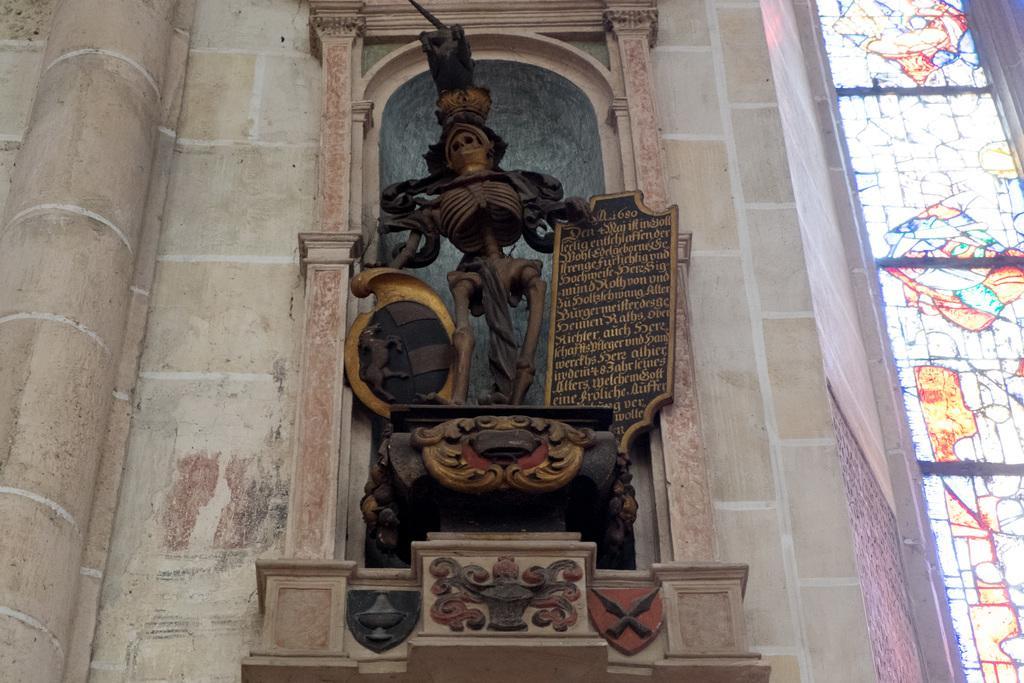Describe this image in one or two sentences. In the center of the image there is a statue. In the background we can see wall. 